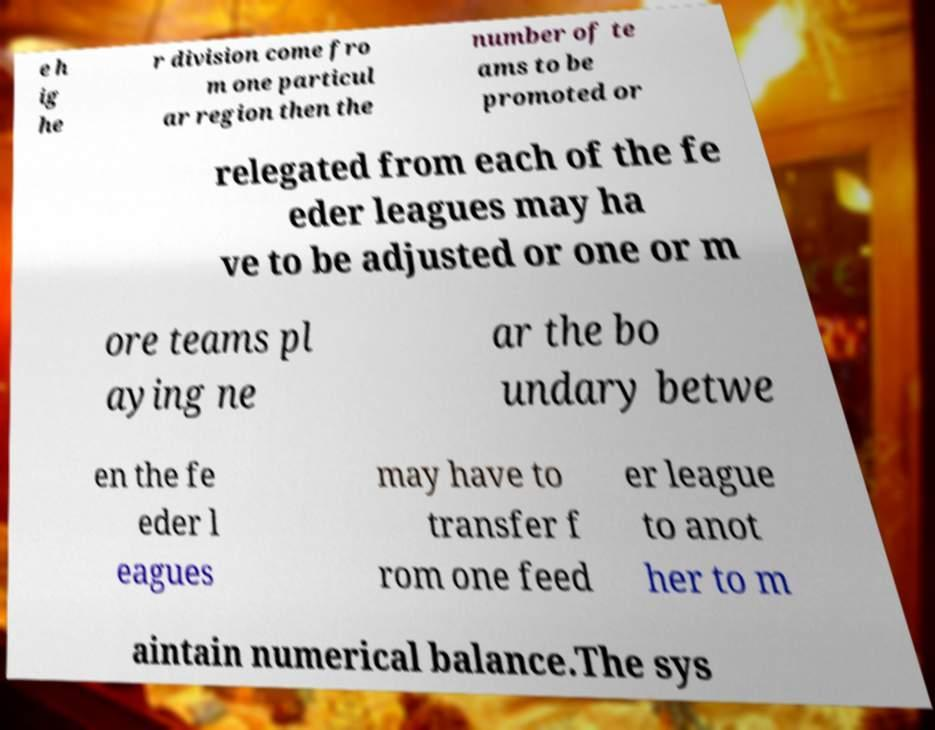Could you assist in decoding the text presented in this image and type it out clearly? e h ig he r division come fro m one particul ar region then the number of te ams to be promoted or relegated from each of the fe eder leagues may ha ve to be adjusted or one or m ore teams pl aying ne ar the bo undary betwe en the fe eder l eagues may have to transfer f rom one feed er league to anot her to m aintain numerical balance.The sys 